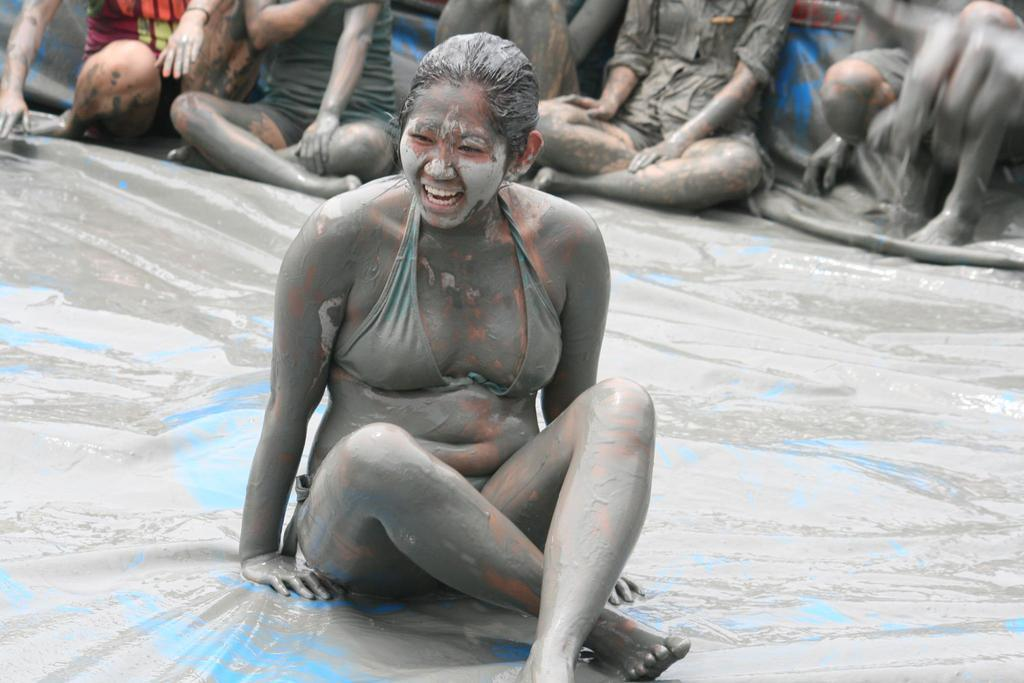Who is the main subject in the image? There is a woman in the image. What is the woman doing in the image? The woman is sitting on a platform and smiling. Can you describe the presence of other people be observed in the image? Yes, there are people in the background of the image. What type of cork can be seen in the woman's hair in the image? There is no cork present in the woman's hair or in the image. What body part is the woman using to balance on the platform? The provided facts do not specify which body part the woman is using to balance on the platform. 